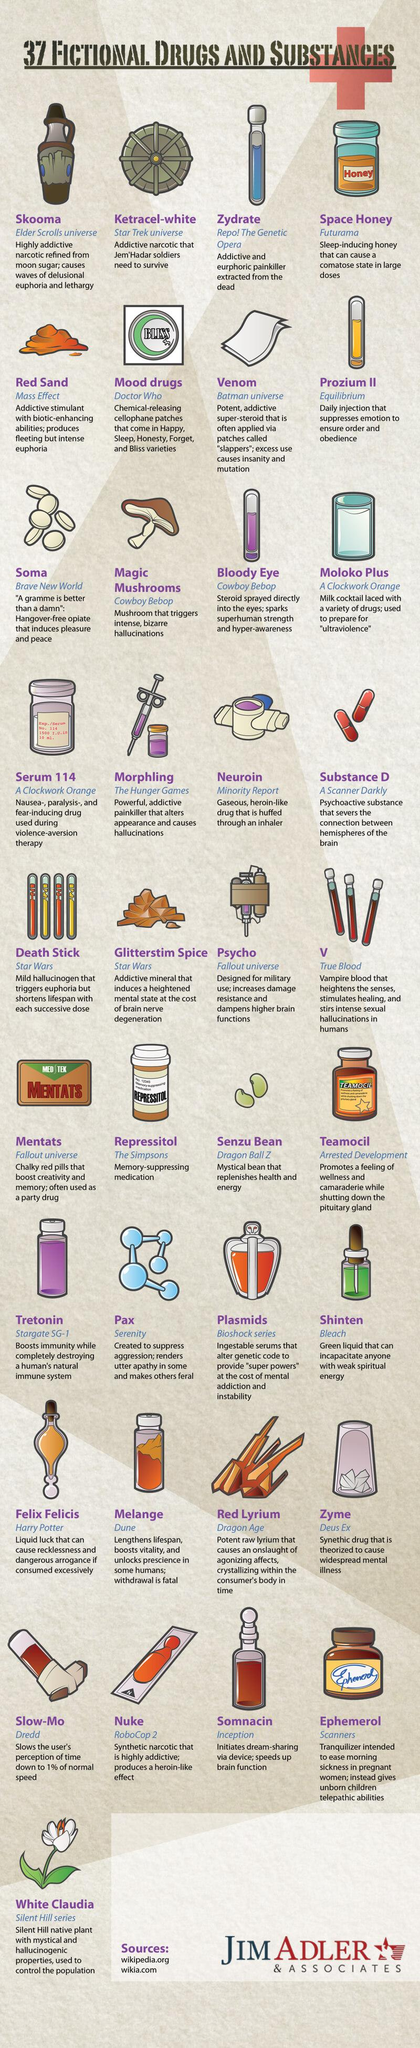Indicate a few pertinent items in this graphic. The fictional drug, known as "slow-mo," slows the user's perception of time down to 1% of normal speed. In the fictional work "Scanners," the drug Ephemerol is mentioned. The drug Repressitol is used for memory-suppressing purposes. The drug mentioned in A Clockwork Orange is serum 114. Prozium II is a fictional drug that is administered daily via injection to suppress emotions in order to maintain order and obedience in society. 